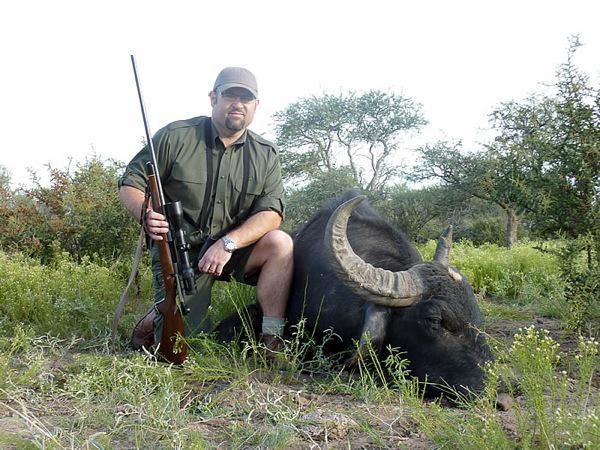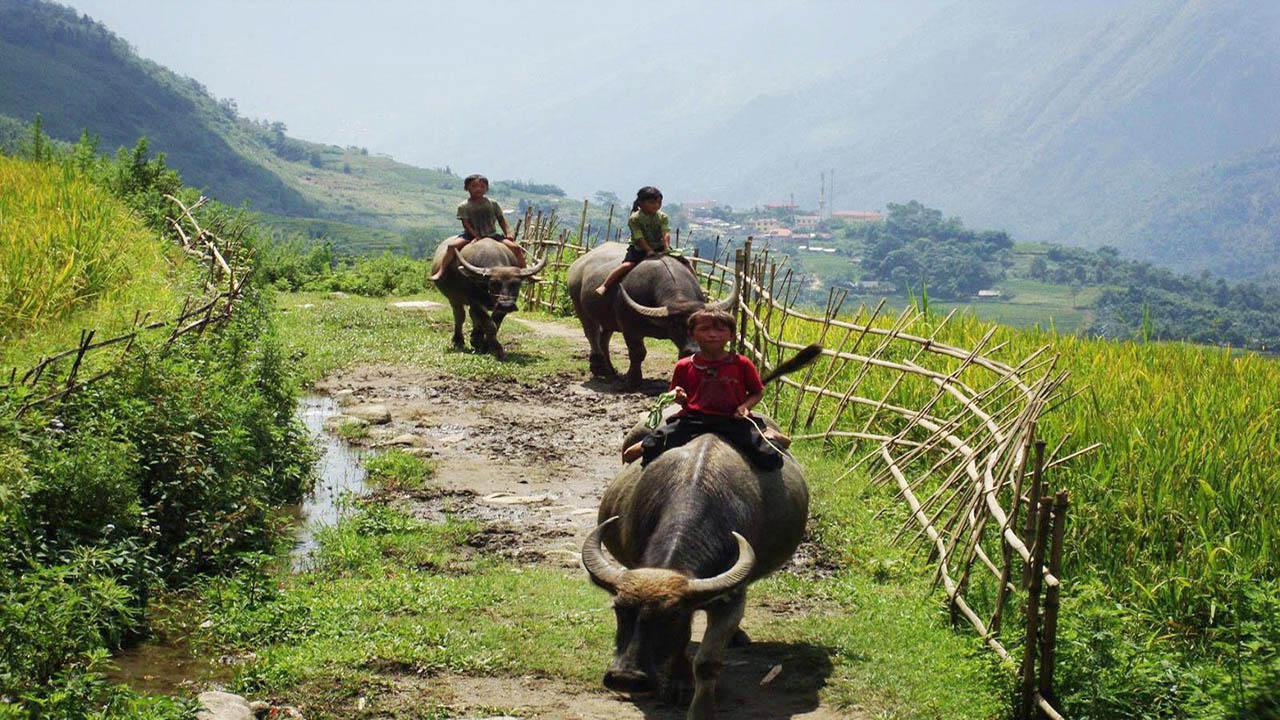The first image is the image on the left, the second image is the image on the right. Examine the images to the left and right. Is the description "One image shows a man holding a gun posed next to a dead water buffalo, and the other image shows at least one person riding on the back of a water buffalo." accurate? Answer yes or no. Yes. The first image is the image on the left, the second image is the image on the right. Given the left and right images, does the statement "The left image contains one hunter near one dead water buffalo." hold true? Answer yes or no. Yes. 